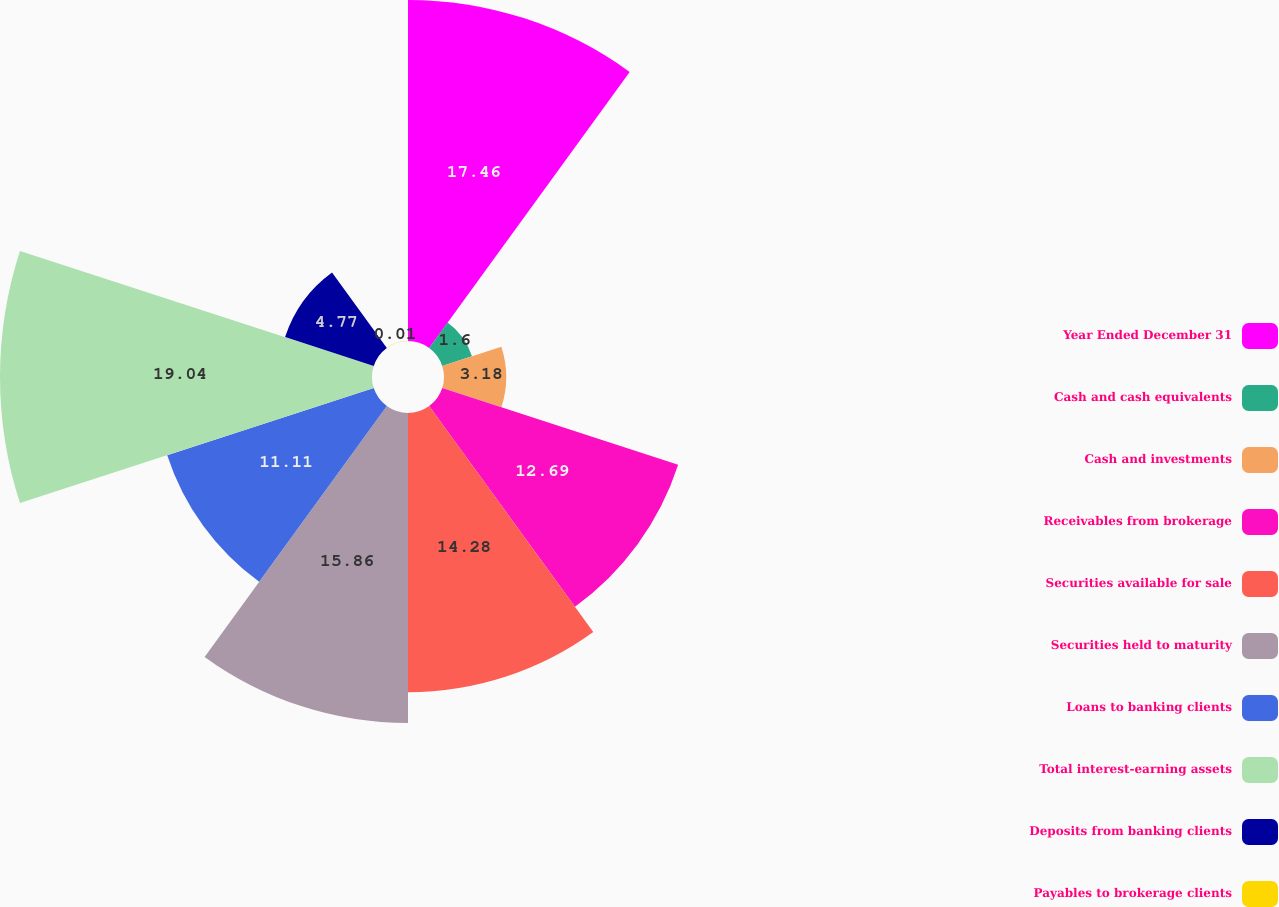Convert chart to OTSL. <chart><loc_0><loc_0><loc_500><loc_500><pie_chart><fcel>Year Ended December 31<fcel>Cash and cash equivalents<fcel>Cash and investments<fcel>Receivables from brokerage<fcel>Securities available for sale<fcel>Securities held to maturity<fcel>Loans to banking clients<fcel>Total interest-earning assets<fcel>Deposits from banking clients<fcel>Payables to brokerage clients<nl><fcel>17.45%<fcel>1.6%<fcel>3.18%<fcel>12.69%<fcel>14.28%<fcel>15.86%<fcel>11.11%<fcel>19.03%<fcel>4.77%<fcel>0.01%<nl></chart> 